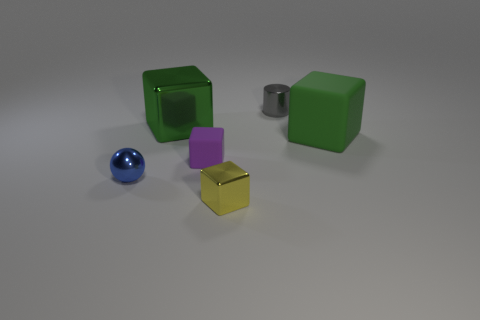The green block that is made of the same material as the yellow block is what size? The green block that shares the same glossy texture and appearance as the yellow block appears to be large in size, similar to one of the other green blocks visible in the image, suggesting that both were designed to be proportionally similar. 